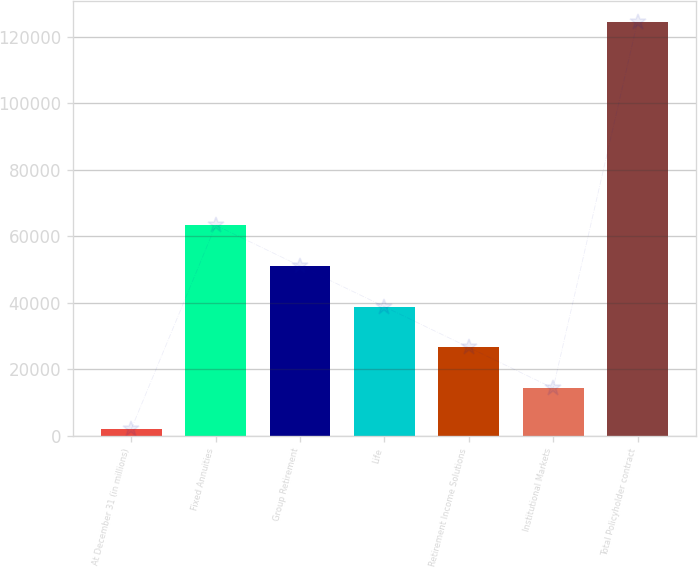Convert chart to OTSL. <chart><loc_0><loc_0><loc_500><loc_500><bar_chart><fcel>At December 31 (in millions)<fcel>Fixed Annuities<fcel>Group Retirement<fcel>Life<fcel>Retirement Income Solutions<fcel>Institutional Markets<fcel>Total Policyholder contract<nl><fcel>2014<fcel>63313.5<fcel>51053.6<fcel>38793.7<fcel>26533.8<fcel>14273.9<fcel>124613<nl></chart> 